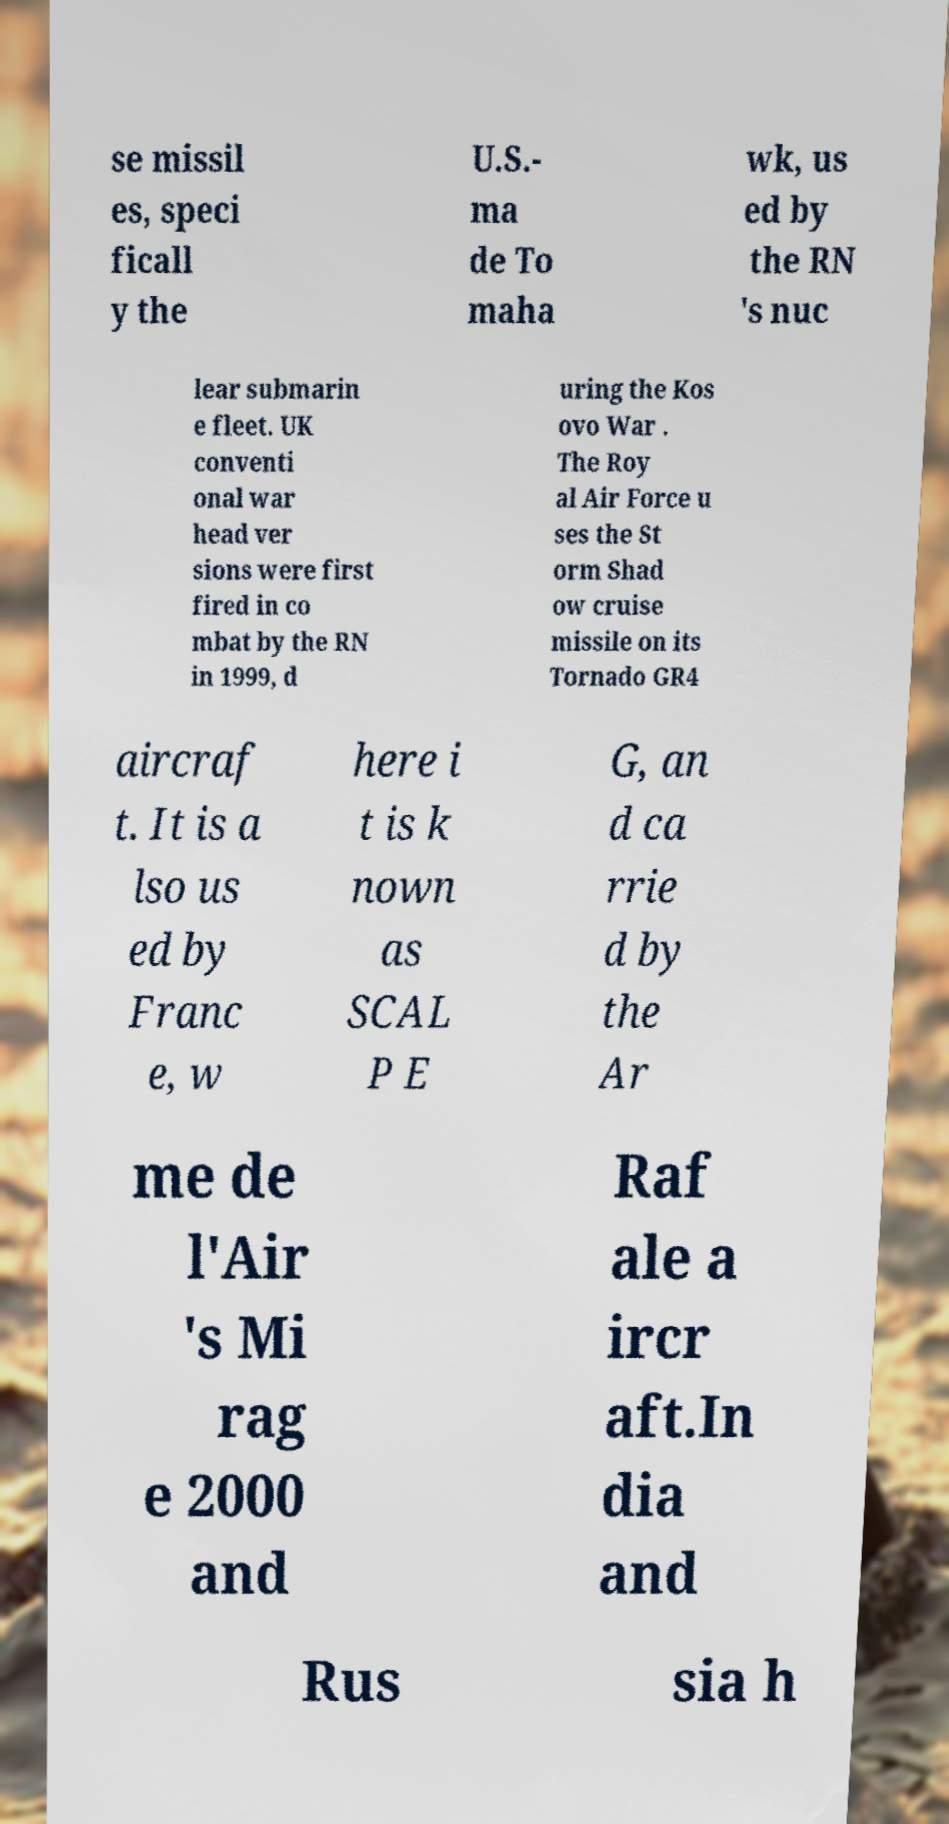I need the written content from this picture converted into text. Can you do that? se missil es, speci ficall y the U.S.- ma de To maha wk, us ed by the RN 's nuc lear submarin e fleet. UK conventi onal war head ver sions were first fired in co mbat by the RN in 1999, d uring the Kos ovo War . The Roy al Air Force u ses the St orm Shad ow cruise missile on its Tornado GR4 aircraf t. It is a lso us ed by Franc e, w here i t is k nown as SCAL P E G, an d ca rrie d by the Ar me de l'Air 's Mi rag e 2000 and Raf ale a ircr aft.In dia and Rus sia h 